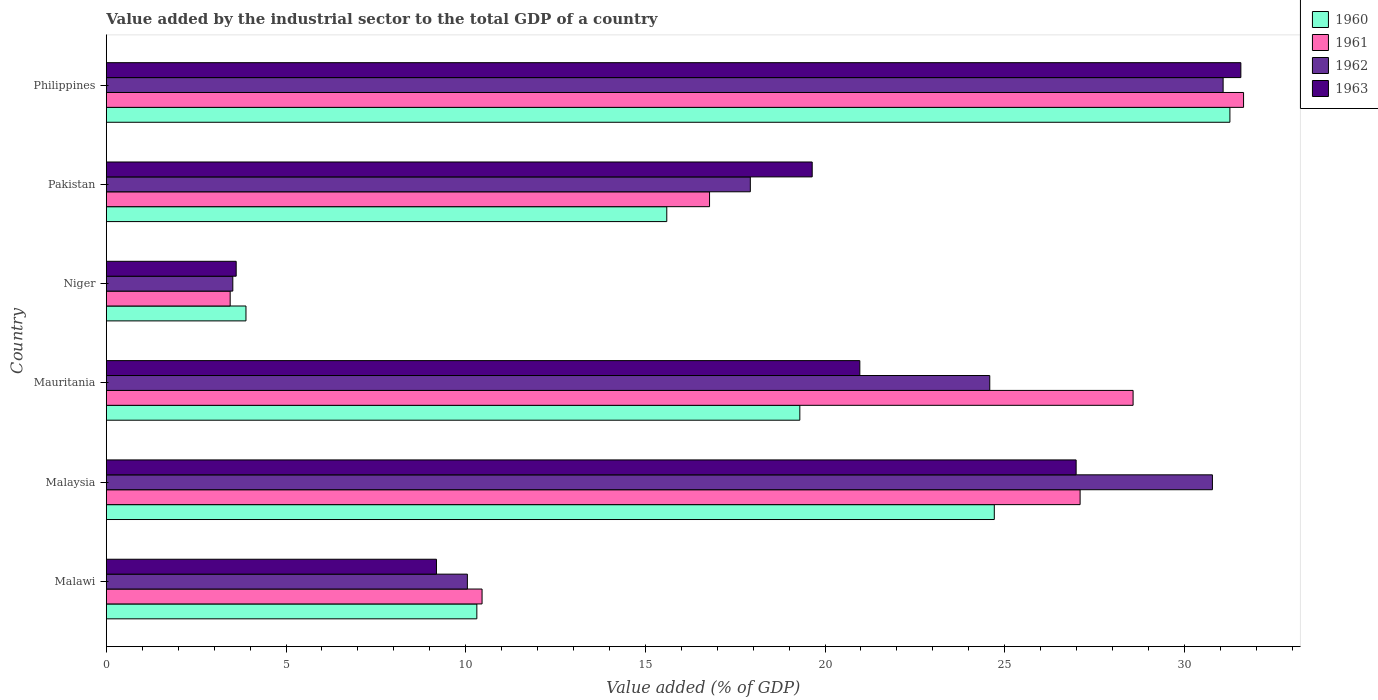How many different coloured bars are there?
Provide a succinct answer. 4. How many groups of bars are there?
Your answer should be very brief. 6. How many bars are there on the 4th tick from the top?
Make the answer very short. 4. What is the label of the 1st group of bars from the top?
Provide a short and direct response. Philippines. In how many cases, is the number of bars for a given country not equal to the number of legend labels?
Your answer should be very brief. 0. What is the value added by the industrial sector to the total GDP in 1960 in Malaysia?
Keep it short and to the point. 24.71. Across all countries, what is the maximum value added by the industrial sector to the total GDP in 1962?
Provide a short and direct response. 31.08. Across all countries, what is the minimum value added by the industrial sector to the total GDP in 1963?
Ensure brevity in your answer.  3.61. In which country was the value added by the industrial sector to the total GDP in 1962 maximum?
Make the answer very short. Philippines. In which country was the value added by the industrial sector to the total GDP in 1961 minimum?
Provide a short and direct response. Niger. What is the total value added by the industrial sector to the total GDP in 1962 in the graph?
Provide a short and direct response. 117.94. What is the difference between the value added by the industrial sector to the total GDP in 1962 in Niger and that in Pakistan?
Provide a short and direct response. -14.4. What is the difference between the value added by the industrial sector to the total GDP in 1960 in Niger and the value added by the industrial sector to the total GDP in 1963 in Philippines?
Provide a short and direct response. -27.69. What is the average value added by the industrial sector to the total GDP in 1962 per country?
Give a very brief answer. 19.66. What is the difference between the value added by the industrial sector to the total GDP in 1963 and value added by the industrial sector to the total GDP in 1960 in Malaysia?
Your answer should be compact. 2.28. What is the ratio of the value added by the industrial sector to the total GDP in 1962 in Mauritania to that in Pakistan?
Your answer should be very brief. 1.37. Is the difference between the value added by the industrial sector to the total GDP in 1963 in Malawi and Pakistan greater than the difference between the value added by the industrial sector to the total GDP in 1960 in Malawi and Pakistan?
Offer a terse response. No. What is the difference between the highest and the second highest value added by the industrial sector to the total GDP in 1960?
Your answer should be very brief. 6.56. What is the difference between the highest and the lowest value added by the industrial sector to the total GDP in 1960?
Your answer should be very brief. 27.38. How many bars are there?
Keep it short and to the point. 24. What is the difference between two consecutive major ticks on the X-axis?
Keep it short and to the point. 5. Are the values on the major ticks of X-axis written in scientific E-notation?
Ensure brevity in your answer.  No. Where does the legend appear in the graph?
Your response must be concise. Top right. What is the title of the graph?
Ensure brevity in your answer.  Value added by the industrial sector to the total GDP of a country. What is the label or title of the X-axis?
Your answer should be very brief. Value added (% of GDP). What is the Value added (% of GDP) in 1960 in Malawi?
Provide a succinct answer. 10.31. What is the Value added (% of GDP) of 1961 in Malawi?
Make the answer very short. 10.46. What is the Value added (% of GDP) in 1962 in Malawi?
Provide a short and direct response. 10.05. What is the Value added (% of GDP) of 1963 in Malawi?
Your answer should be very brief. 9.19. What is the Value added (% of GDP) of 1960 in Malaysia?
Give a very brief answer. 24.71. What is the Value added (% of GDP) in 1961 in Malaysia?
Offer a very short reply. 27.1. What is the Value added (% of GDP) of 1962 in Malaysia?
Your answer should be compact. 30.78. What is the Value added (% of GDP) of 1963 in Malaysia?
Your answer should be compact. 26.99. What is the Value added (% of GDP) in 1960 in Mauritania?
Provide a succinct answer. 19.3. What is the Value added (% of GDP) of 1961 in Mauritania?
Your response must be concise. 28.57. What is the Value added (% of GDP) in 1962 in Mauritania?
Ensure brevity in your answer.  24.59. What is the Value added (% of GDP) in 1963 in Mauritania?
Keep it short and to the point. 20.97. What is the Value added (% of GDP) in 1960 in Niger?
Make the answer very short. 3.89. What is the Value added (% of GDP) in 1961 in Niger?
Keep it short and to the point. 3.45. What is the Value added (% of GDP) in 1962 in Niger?
Your answer should be very brief. 3.52. What is the Value added (% of GDP) in 1963 in Niger?
Your response must be concise. 3.61. What is the Value added (% of GDP) in 1960 in Pakistan?
Provide a succinct answer. 15.6. What is the Value added (% of GDP) of 1961 in Pakistan?
Your answer should be compact. 16.79. What is the Value added (% of GDP) of 1962 in Pakistan?
Keep it short and to the point. 17.92. What is the Value added (% of GDP) in 1963 in Pakistan?
Provide a short and direct response. 19.64. What is the Value added (% of GDP) in 1960 in Philippines?
Your response must be concise. 31.27. What is the Value added (% of GDP) in 1961 in Philippines?
Provide a short and direct response. 31.65. What is the Value added (% of GDP) in 1962 in Philippines?
Give a very brief answer. 31.08. What is the Value added (% of GDP) of 1963 in Philippines?
Offer a terse response. 31.57. Across all countries, what is the maximum Value added (% of GDP) of 1960?
Keep it short and to the point. 31.27. Across all countries, what is the maximum Value added (% of GDP) of 1961?
Ensure brevity in your answer.  31.65. Across all countries, what is the maximum Value added (% of GDP) in 1962?
Your answer should be compact. 31.08. Across all countries, what is the maximum Value added (% of GDP) of 1963?
Give a very brief answer. 31.57. Across all countries, what is the minimum Value added (% of GDP) in 1960?
Your response must be concise. 3.89. Across all countries, what is the minimum Value added (% of GDP) in 1961?
Offer a very short reply. 3.45. Across all countries, what is the minimum Value added (% of GDP) in 1962?
Your answer should be compact. 3.52. Across all countries, what is the minimum Value added (% of GDP) in 1963?
Your response must be concise. 3.61. What is the total Value added (% of GDP) of 1960 in the graph?
Your answer should be compact. 105.07. What is the total Value added (% of GDP) of 1961 in the graph?
Make the answer very short. 118.01. What is the total Value added (% of GDP) in 1962 in the graph?
Your answer should be compact. 117.94. What is the total Value added (% of GDP) of 1963 in the graph?
Offer a terse response. 111.98. What is the difference between the Value added (% of GDP) of 1960 in Malawi and that in Malaysia?
Ensure brevity in your answer.  -14.4. What is the difference between the Value added (% of GDP) of 1961 in Malawi and that in Malaysia?
Your answer should be compact. -16.64. What is the difference between the Value added (% of GDP) of 1962 in Malawi and that in Malaysia?
Keep it short and to the point. -20.73. What is the difference between the Value added (% of GDP) in 1963 in Malawi and that in Malaysia?
Offer a very short reply. -17.8. What is the difference between the Value added (% of GDP) of 1960 in Malawi and that in Mauritania?
Provide a short and direct response. -8.99. What is the difference between the Value added (% of GDP) in 1961 in Malawi and that in Mauritania?
Ensure brevity in your answer.  -18.12. What is the difference between the Value added (% of GDP) of 1962 in Malawi and that in Mauritania?
Provide a short and direct response. -14.54. What is the difference between the Value added (% of GDP) of 1963 in Malawi and that in Mauritania?
Provide a short and direct response. -11.78. What is the difference between the Value added (% of GDP) of 1960 in Malawi and that in Niger?
Your answer should be compact. 6.43. What is the difference between the Value added (% of GDP) of 1961 in Malawi and that in Niger?
Your response must be concise. 7.01. What is the difference between the Value added (% of GDP) of 1962 in Malawi and that in Niger?
Your response must be concise. 6.53. What is the difference between the Value added (% of GDP) in 1963 in Malawi and that in Niger?
Offer a terse response. 5.57. What is the difference between the Value added (% of GDP) of 1960 in Malawi and that in Pakistan?
Your response must be concise. -5.29. What is the difference between the Value added (% of GDP) in 1961 in Malawi and that in Pakistan?
Give a very brief answer. -6.33. What is the difference between the Value added (% of GDP) in 1962 in Malawi and that in Pakistan?
Provide a succinct answer. -7.87. What is the difference between the Value added (% of GDP) in 1963 in Malawi and that in Pakistan?
Your answer should be compact. -10.46. What is the difference between the Value added (% of GDP) in 1960 in Malawi and that in Philippines?
Provide a succinct answer. -20.96. What is the difference between the Value added (% of GDP) of 1961 in Malawi and that in Philippines?
Your response must be concise. -21.19. What is the difference between the Value added (% of GDP) in 1962 in Malawi and that in Philippines?
Your answer should be very brief. -21.03. What is the difference between the Value added (% of GDP) of 1963 in Malawi and that in Philippines?
Offer a very short reply. -22.39. What is the difference between the Value added (% of GDP) in 1960 in Malaysia and that in Mauritania?
Your answer should be compact. 5.41. What is the difference between the Value added (% of GDP) of 1961 in Malaysia and that in Mauritania?
Your response must be concise. -1.47. What is the difference between the Value added (% of GDP) in 1962 in Malaysia and that in Mauritania?
Ensure brevity in your answer.  6.2. What is the difference between the Value added (% of GDP) of 1963 in Malaysia and that in Mauritania?
Make the answer very short. 6.02. What is the difference between the Value added (% of GDP) in 1960 in Malaysia and that in Niger?
Give a very brief answer. 20.83. What is the difference between the Value added (% of GDP) of 1961 in Malaysia and that in Niger?
Make the answer very short. 23.65. What is the difference between the Value added (% of GDP) in 1962 in Malaysia and that in Niger?
Ensure brevity in your answer.  27.26. What is the difference between the Value added (% of GDP) in 1963 in Malaysia and that in Niger?
Give a very brief answer. 23.38. What is the difference between the Value added (% of GDP) of 1960 in Malaysia and that in Pakistan?
Offer a very short reply. 9.11. What is the difference between the Value added (% of GDP) of 1961 in Malaysia and that in Pakistan?
Provide a succinct answer. 10.31. What is the difference between the Value added (% of GDP) of 1962 in Malaysia and that in Pakistan?
Ensure brevity in your answer.  12.86. What is the difference between the Value added (% of GDP) in 1963 in Malaysia and that in Pakistan?
Your answer should be compact. 7.35. What is the difference between the Value added (% of GDP) in 1960 in Malaysia and that in Philippines?
Offer a very short reply. -6.56. What is the difference between the Value added (% of GDP) in 1961 in Malaysia and that in Philippines?
Your response must be concise. -4.55. What is the difference between the Value added (% of GDP) of 1962 in Malaysia and that in Philippines?
Offer a very short reply. -0.3. What is the difference between the Value added (% of GDP) of 1963 in Malaysia and that in Philippines?
Your answer should be very brief. -4.58. What is the difference between the Value added (% of GDP) of 1960 in Mauritania and that in Niger?
Keep it short and to the point. 15.41. What is the difference between the Value added (% of GDP) of 1961 in Mauritania and that in Niger?
Make the answer very short. 25.13. What is the difference between the Value added (% of GDP) of 1962 in Mauritania and that in Niger?
Your answer should be compact. 21.07. What is the difference between the Value added (% of GDP) in 1963 in Mauritania and that in Niger?
Your answer should be very brief. 17.36. What is the difference between the Value added (% of GDP) in 1960 in Mauritania and that in Pakistan?
Make the answer very short. 3.7. What is the difference between the Value added (% of GDP) in 1961 in Mauritania and that in Pakistan?
Your response must be concise. 11.79. What is the difference between the Value added (% of GDP) in 1962 in Mauritania and that in Pakistan?
Your answer should be compact. 6.66. What is the difference between the Value added (% of GDP) of 1963 in Mauritania and that in Pakistan?
Ensure brevity in your answer.  1.33. What is the difference between the Value added (% of GDP) of 1960 in Mauritania and that in Philippines?
Provide a succinct answer. -11.97. What is the difference between the Value added (% of GDP) in 1961 in Mauritania and that in Philippines?
Your answer should be compact. -3.07. What is the difference between the Value added (% of GDP) in 1962 in Mauritania and that in Philippines?
Offer a very short reply. -6.49. What is the difference between the Value added (% of GDP) of 1963 in Mauritania and that in Philippines?
Make the answer very short. -10.6. What is the difference between the Value added (% of GDP) of 1960 in Niger and that in Pakistan?
Provide a succinct answer. -11.71. What is the difference between the Value added (% of GDP) in 1961 in Niger and that in Pakistan?
Provide a short and direct response. -13.34. What is the difference between the Value added (% of GDP) of 1962 in Niger and that in Pakistan?
Give a very brief answer. -14.4. What is the difference between the Value added (% of GDP) of 1963 in Niger and that in Pakistan?
Provide a succinct answer. -16.03. What is the difference between the Value added (% of GDP) of 1960 in Niger and that in Philippines?
Your answer should be very brief. -27.38. What is the difference between the Value added (% of GDP) in 1961 in Niger and that in Philippines?
Make the answer very short. -28.2. What is the difference between the Value added (% of GDP) in 1962 in Niger and that in Philippines?
Offer a terse response. -27.56. What is the difference between the Value added (% of GDP) of 1963 in Niger and that in Philippines?
Ensure brevity in your answer.  -27.96. What is the difference between the Value added (% of GDP) in 1960 in Pakistan and that in Philippines?
Your answer should be compact. -15.67. What is the difference between the Value added (% of GDP) of 1961 in Pakistan and that in Philippines?
Keep it short and to the point. -14.86. What is the difference between the Value added (% of GDP) of 1962 in Pakistan and that in Philippines?
Your response must be concise. -13.16. What is the difference between the Value added (% of GDP) in 1963 in Pakistan and that in Philippines?
Provide a succinct answer. -11.93. What is the difference between the Value added (% of GDP) of 1960 in Malawi and the Value added (% of GDP) of 1961 in Malaysia?
Ensure brevity in your answer.  -16.79. What is the difference between the Value added (% of GDP) in 1960 in Malawi and the Value added (% of GDP) in 1962 in Malaysia?
Provide a short and direct response. -20.47. What is the difference between the Value added (% of GDP) in 1960 in Malawi and the Value added (% of GDP) in 1963 in Malaysia?
Make the answer very short. -16.68. What is the difference between the Value added (% of GDP) of 1961 in Malawi and the Value added (% of GDP) of 1962 in Malaysia?
Ensure brevity in your answer.  -20.33. What is the difference between the Value added (% of GDP) in 1961 in Malawi and the Value added (% of GDP) in 1963 in Malaysia?
Offer a terse response. -16.53. What is the difference between the Value added (% of GDP) in 1962 in Malawi and the Value added (% of GDP) in 1963 in Malaysia?
Provide a succinct answer. -16.94. What is the difference between the Value added (% of GDP) in 1960 in Malawi and the Value added (% of GDP) in 1961 in Mauritania?
Provide a short and direct response. -18.26. What is the difference between the Value added (% of GDP) in 1960 in Malawi and the Value added (% of GDP) in 1962 in Mauritania?
Offer a terse response. -14.27. What is the difference between the Value added (% of GDP) in 1960 in Malawi and the Value added (% of GDP) in 1963 in Mauritania?
Your response must be concise. -10.66. What is the difference between the Value added (% of GDP) of 1961 in Malawi and the Value added (% of GDP) of 1962 in Mauritania?
Your answer should be compact. -14.13. What is the difference between the Value added (% of GDP) in 1961 in Malawi and the Value added (% of GDP) in 1963 in Mauritania?
Make the answer very short. -10.51. What is the difference between the Value added (% of GDP) in 1962 in Malawi and the Value added (% of GDP) in 1963 in Mauritania?
Offer a very short reply. -10.92. What is the difference between the Value added (% of GDP) of 1960 in Malawi and the Value added (% of GDP) of 1961 in Niger?
Ensure brevity in your answer.  6.86. What is the difference between the Value added (% of GDP) of 1960 in Malawi and the Value added (% of GDP) of 1962 in Niger?
Offer a very short reply. 6.79. What is the difference between the Value added (% of GDP) in 1960 in Malawi and the Value added (% of GDP) in 1963 in Niger?
Provide a succinct answer. 6.7. What is the difference between the Value added (% of GDP) of 1961 in Malawi and the Value added (% of GDP) of 1962 in Niger?
Offer a very short reply. 6.94. What is the difference between the Value added (% of GDP) of 1961 in Malawi and the Value added (% of GDP) of 1963 in Niger?
Provide a short and direct response. 6.84. What is the difference between the Value added (% of GDP) in 1962 in Malawi and the Value added (% of GDP) in 1963 in Niger?
Make the answer very short. 6.43. What is the difference between the Value added (% of GDP) of 1960 in Malawi and the Value added (% of GDP) of 1961 in Pakistan?
Your answer should be very brief. -6.48. What is the difference between the Value added (% of GDP) in 1960 in Malawi and the Value added (% of GDP) in 1962 in Pakistan?
Your answer should be very brief. -7.61. What is the difference between the Value added (% of GDP) of 1960 in Malawi and the Value added (% of GDP) of 1963 in Pakistan?
Give a very brief answer. -9.33. What is the difference between the Value added (% of GDP) in 1961 in Malawi and the Value added (% of GDP) in 1962 in Pakistan?
Your response must be concise. -7.47. What is the difference between the Value added (% of GDP) in 1961 in Malawi and the Value added (% of GDP) in 1963 in Pakistan?
Ensure brevity in your answer.  -9.19. What is the difference between the Value added (% of GDP) in 1962 in Malawi and the Value added (% of GDP) in 1963 in Pakistan?
Provide a succinct answer. -9.6. What is the difference between the Value added (% of GDP) of 1960 in Malawi and the Value added (% of GDP) of 1961 in Philippines?
Give a very brief answer. -21.34. What is the difference between the Value added (% of GDP) of 1960 in Malawi and the Value added (% of GDP) of 1962 in Philippines?
Give a very brief answer. -20.77. What is the difference between the Value added (% of GDP) in 1960 in Malawi and the Value added (% of GDP) in 1963 in Philippines?
Your answer should be compact. -21.26. What is the difference between the Value added (% of GDP) of 1961 in Malawi and the Value added (% of GDP) of 1962 in Philippines?
Your answer should be compact. -20.62. What is the difference between the Value added (% of GDP) in 1961 in Malawi and the Value added (% of GDP) in 1963 in Philippines?
Offer a terse response. -21.12. What is the difference between the Value added (% of GDP) of 1962 in Malawi and the Value added (% of GDP) of 1963 in Philippines?
Give a very brief answer. -21.53. What is the difference between the Value added (% of GDP) in 1960 in Malaysia and the Value added (% of GDP) in 1961 in Mauritania?
Ensure brevity in your answer.  -3.86. What is the difference between the Value added (% of GDP) of 1960 in Malaysia and the Value added (% of GDP) of 1962 in Mauritania?
Your answer should be compact. 0.13. What is the difference between the Value added (% of GDP) of 1960 in Malaysia and the Value added (% of GDP) of 1963 in Mauritania?
Provide a short and direct response. 3.74. What is the difference between the Value added (% of GDP) in 1961 in Malaysia and the Value added (% of GDP) in 1962 in Mauritania?
Offer a terse response. 2.51. What is the difference between the Value added (% of GDP) in 1961 in Malaysia and the Value added (% of GDP) in 1963 in Mauritania?
Provide a short and direct response. 6.13. What is the difference between the Value added (% of GDP) of 1962 in Malaysia and the Value added (% of GDP) of 1963 in Mauritania?
Offer a very short reply. 9.81. What is the difference between the Value added (% of GDP) of 1960 in Malaysia and the Value added (% of GDP) of 1961 in Niger?
Offer a terse response. 21.27. What is the difference between the Value added (% of GDP) in 1960 in Malaysia and the Value added (% of GDP) in 1962 in Niger?
Offer a terse response. 21.19. What is the difference between the Value added (% of GDP) of 1960 in Malaysia and the Value added (% of GDP) of 1963 in Niger?
Ensure brevity in your answer.  21.1. What is the difference between the Value added (% of GDP) in 1961 in Malaysia and the Value added (% of GDP) in 1962 in Niger?
Your answer should be compact. 23.58. What is the difference between the Value added (% of GDP) in 1961 in Malaysia and the Value added (% of GDP) in 1963 in Niger?
Give a very brief answer. 23.49. What is the difference between the Value added (% of GDP) in 1962 in Malaysia and the Value added (% of GDP) in 1963 in Niger?
Your answer should be very brief. 27.17. What is the difference between the Value added (% of GDP) in 1960 in Malaysia and the Value added (% of GDP) in 1961 in Pakistan?
Your answer should be compact. 7.92. What is the difference between the Value added (% of GDP) in 1960 in Malaysia and the Value added (% of GDP) in 1962 in Pakistan?
Your answer should be compact. 6.79. What is the difference between the Value added (% of GDP) of 1960 in Malaysia and the Value added (% of GDP) of 1963 in Pakistan?
Offer a terse response. 5.07. What is the difference between the Value added (% of GDP) of 1961 in Malaysia and the Value added (% of GDP) of 1962 in Pakistan?
Your answer should be compact. 9.18. What is the difference between the Value added (% of GDP) of 1961 in Malaysia and the Value added (% of GDP) of 1963 in Pakistan?
Your answer should be compact. 7.46. What is the difference between the Value added (% of GDP) of 1962 in Malaysia and the Value added (% of GDP) of 1963 in Pakistan?
Your answer should be very brief. 11.14. What is the difference between the Value added (% of GDP) in 1960 in Malaysia and the Value added (% of GDP) in 1961 in Philippines?
Offer a terse response. -6.94. What is the difference between the Value added (% of GDP) in 1960 in Malaysia and the Value added (% of GDP) in 1962 in Philippines?
Your response must be concise. -6.37. What is the difference between the Value added (% of GDP) of 1960 in Malaysia and the Value added (% of GDP) of 1963 in Philippines?
Keep it short and to the point. -6.86. What is the difference between the Value added (% of GDP) of 1961 in Malaysia and the Value added (% of GDP) of 1962 in Philippines?
Provide a short and direct response. -3.98. What is the difference between the Value added (% of GDP) in 1961 in Malaysia and the Value added (% of GDP) in 1963 in Philippines?
Provide a short and direct response. -4.47. What is the difference between the Value added (% of GDP) in 1962 in Malaysia and the Value added (% of GDP) in 1963 in Philippines?
Provide a succinct answer. -0.79. What is the difference between the Value added (% of GDP) in 1960 in Mauritania and the Value added (% of GDP) in 1961 in Niger?
Provide a succinct answer. 15.85. What is the difference between the Value added (% of GDP) in 1960 in Mauritania and the Value added (% of GDP) in 1962 in Niger?
Provide a succinct answer. 15.78. What is the difference between the Value added (% of GDP) in 1960 in Mauritania and the Value added (% of GDP) in 1963 in Niger?
Your answer should be compact. 15.69. What is the difference between the Value added (% of GDP) in 1961 in Mauritania and the Value added (% of GDP) in 1962 in Niger?
Make the answer very short. 25.05. What is the difference between the Value added (% of GDP) in 1961 in Mauritania and the Value added (% of GDP) in 1963 in Niger?
Ensure brevity in your answer.  24.96. What is the difference between the Value added (% of GDP) of 1962 in Mauritania and the Value added (% of GDP) of 1963 in Niger?
Ensure brevity in your answer.  20.97. What is the difference between the Value added (% of GDP) of 1960 in Mauritania and the Value added (% of GDP) of 1961 in Pakistan?
Offer a very short reply. 2.51. What is the difference between the Value added (% of GDP) of 1960 in Mauritania and the Value added (% of GDP) of 1962 in Pakistan?
Give a very brief answer. 1.38. What is the difference between the Value added (% of GDP) in 1960 in Mauritania and the Value added (% of GDP) in 1963 in Pakistan?
Provide a succinct answer. -0.34. What is the difference between the Value added (% of GDP) of 1961 in Mauritania and the Value added (% of GDP) of 1962 in Pakistan?
Keep it short and to the point. 10.65. What is the difference between the Value added (% of GDP) of 1961 in Mauritania and the Value added (% of GDP) of 1963 in Pakistan?
Offer a terse response. 8.93. What is the difference between the Value added (% of GDP) of 1962 in Mauritania and the Value added (% of GDP) of 1963 in Pakistan?
Make the answer very short. 4.94. What is the difference between the Value added (% of GDP) of 1960 in Mauritania and the Value added (% of GDP) of 1961 in Philippines?
Offer a terse response. -12.35. What is the difference between the Value added (% of GDP) in 1960 in Mauritania and the Value added (% of GDP) in 1962 in Philippines?
Your response must be concise. -11.78. What is the difference between the Value added (% of GDP) of 1960 in Mauritania and the Value added (% of GDP) of 1963 in Philippines?
Make the answer very short. -12.27. What is the difference between the Value added (% of GDP) in 1961 in Mauritania and the Value added (% of GDP) in 1962 in Philippines?
Give a very brief answer. -2.51. What is the difference between the Value added (% of GDP) in 1961 in Mauritania and the Value added (% of GDP) in 1963 in Philippines?
Offer a very short reply. -3. What is the difference between the Value added (% of GDP) of 1962 in Mauritania and the Value added (% of GDP) of 1963 in Philippines?
Provide a succinct answer. -6.99. What is the difference between the Value added (% of GDP) of 1960 in Niger and the Value added (% of GDP) of 1961 in Pakistan?
Offer a very short reply. -12.9. What is the difference between the Value added (% of GDP) in 1960 in Niger and the Value added (% of GDP) in 1962 in Pakistan?
Make the answer very short. -14.04. What is the difference between the Value added (% of GDP) of 1960 in Niger and the Value added (% of GDP) of 1963 in Pakistan?
Make the answer very short. -15.76. What is the difference between the Value added (% of GDP) of 1961 in Niger and the Value added (% of GDP) of 1962 in Pakistan?
Provide a succinct answer. -14.48. What is the difference between the Value added (% of GDP) of 1961 in Niger and the Value added (% of GDP) of 1963 in Pakistan?
Offer a terse response. -16.2. What is the difference between the Value added (% of GDP) of 1962 in Niger and the Value added (% of GDP) of 1963 in Pakistan?
Ensure brevity in your answer.  -16.12. What is the difference between the Value added (% of GDP) of 1960 in Niger and the Value added (% of GDP) of 1961 in Philippines?
Keep it short and to the point. -27.76. What is the difference between the Value added (% of GDP) in 1960 in Niger and the Value added (% of GDP) in 1962 in Philippines?
Offer a very short reply. -27.19. What is the difference between the Value added (% of GDP) in 1960 in Niger and the Value added (% of GDP) in 1963 in Philippines?
Your answer should be compact. -27.69. What is the difference between the Value added (% of GDP) of 1961 in Niger and the Value added (% of GDP) of 1962 in Philippines?
Your response must be concise. -27.63. What is the difference between the Value added (% of GDP) in 1961 in Niger and the Value added (% of GDP) in 1963 in Philippines?
Your response must be concise. -28.13. What is the difference between the Value added (% of GDP) of 1962 in Niger and the Value added (% of GDP) of 1963 in Philippines?
Offer a terse response. -28.05. What is the difference between the Value added (% of GDP) in 1960 in Pakistan and the Value added (% of GDP) in 1961 in Philippines?
Your response must be concise. -16.05. What is the difference between the Value added (% of GDP) in 1960 in Pakistan and the Value added (% of GDP) in 1962 in Philippines?
Your response must be concise. -15.48. What is the difference between the Value added (% of GDP) in 1960 in Pakistan and the Value added (% of GDP) in 1963 in Philippines?
Give a very brief answer. -15.98. What is the difference between the Value added (% of GDP) of 1961 in Pakistan and the Value added (% of GDP) of 1962 in Philippines?
Make the answer very short. -14.29. What is the difference between the Value added (% of GDP) in 1961 in Pakistan and the Value added (% of GDP) in 1963 in Philippines?
Provide a short and direct response. -14.79. What is the difference between the Value added (% of GDP) of 1962 in Pakistan and the Value added (% of GDP) of 1963 in Philippines?
Provide a short and direct response. -13.65. What is the average Value added (% of GDP) in 1960 per country?
Offer a very short reply. 17.51. What is the average Value added (% of GDP) of 1961 per country?
Your answer should be very brief. 19.67. What is the average Value added (% of GDP) of 1962 per country?
Provide a succinct answer. 19.66. What is the average Value added (% of GDP) in 1963 per country?
Offer a terse response. 18.66. What is the difference between the Value added (% of GDP) in 1960 and Value added (% of GDP) in 1961 in Malawi?
Ensure brevity in your answer.  -0.15. What is the difference between the Value added (% of GDP) of 1960 and Value added (% of GDP) of 1962 in Malawi?
Your answer should be compact. 0.26. What is the difference between the Value added (% of GDP) of 1960 and Value added (% of GDP) of 1963 in Malawi?
Keep it short and to the point. 1.12. What is the difference between the Value added (% of GDP) of 1961 and Value added (% of GDP) of 1962 in Malawi?
Your response must be concise. 0.41. What is the difference between the Value added (% of GDP) of 1961 and Value added (% of GDP) of 1963 in Malawi?
Make the answer very short. 1.27. What is the difference between the Value added (% of GDP) in 1962 and Value added (% of GDP) in 1963 in Malawi?
Your answer should be compact. 0.86. What is the difference between the Value added (% of GDP) of 1960 and Value added (% of GDP) of 1961 in Malaysia?
Keep it short and to the point. -2.39. What is the difference between the Value added (% of GDP) of 1960 and Value added (% of GDP) of 1962 in Malaysia?
Provide a succinct answer. -6.07. What is the difference between the Value added (% of GDP) of 1960 and Value added (% of GDP) of 1963 in Malaysia?
Offer a terse response. -2.28. What is the difference between the Value added (% of GDP) in 1961 and Value added (% of GDP) in 1962 in Malaysia?
Your answer should be compact. -3.68. What is the difference between the Value added (% of GDP) in 1961 and Value added (% of GDP) in 1963 in Malaysia?
Offer a very short reply. 0.11. What is the difference between the Value added (% of GDP) in 1962 and Value added (% of GDP) in 1963 in Malaysia?
Offer a very short reply. 3.79. What is the difference between the Value added (% of GDP) of 1960 and Value added (% of GDP) of 1961 in Mauritania?
Make the answer very short. -9.27. What is the difference between the Value added (% of GDP) of 1960 and Value added (% of GDP) of 1962 in Mauritania?
Give a very brief answer. -5.29. What is the difference between the Value added (% of GDP) in 1960 and Value added (% of GDP) in 1963 in Mauritania?
Provide a succinct answer. -1.67. What is the difference between the Value added (% of GDP) in 1961 and Value added (% of GDP) in 1962 in Mauritania?
Offer a very short reply. 3.99. What is the difference between the Value added (% of GDP) of 1961 and Value added (% of GDP) of 1963 in Mauritania?
Your answer should be compact. 7.6. What is the difference between the Value added (% of GDP) in 1962 and Value added (% of GDP) in 1963 in Mauritania?
Provide a succinct answer. 3.62. What is the difference between the Value added (% of GDP) of 1960 and Value added (% of GDP) of 1961 in Niger?
Keep it short and to the point. 0.44. What is the difference between the Value added (% of GDP) in 1960 and Value added (% of GDP) in 1962 in Niger?
Provide a succinct answer. 0.37. What is the difference between the Value added (% of GDP) of 1960 and Value added (% of GDP) of 1963 in Niger?
Offer a terse response. 0.27. What is the difference between the Value added (% of GDP) in 1961 and Value added (% of GDP) in 1962 in Niger?
Your response must be concise. -0.07. What is the difference between the Value added (% of GDP) of 1961 and Value added (% of GDP) of 1963 in Niger?
Offer a very short reply. -0.17. What is the difference between the Value added (% of GDP) in 1962 and Value added (% of GDP) in 1963 in Niger?
Your response must be concise. -0.09. What is the difference between the Value added (% of GDP) of 1960 and Value added (% of GDP) of 1961 in Pakistan?
Make the answer very short. -1.19. What is the difference between the Value added (% of GDP) of 1960 and Value added (% of GDP) of 1962 in Pakistan?
Your answer should be compact. -2.33. What is the difference between the Value added (% of GDP) of 1960 and Value added (% of GDP) of 1963 in Pakistan?
Your response must be concise. -4.05. What is the difference between the Value added (% of GDP) in 1961 and Value added (% of GDP) in 1962 in Pakistan?
Offer a very short reply. -1.14. What is the difference between the Value added (% of GDP) in 1961 and Value added (% of GDP) in 1963 in Pakistan?
Provide a succinct answer. -2.86. What is the difference between the Value added (% of GDP) of 1962 and Value added (% of GDP) of 1963 in Pakistan?
Ensure brevity in your answer.  -1.72. What is the difference between the Value added (% of GDP) of 1960 and Value added (% of GDP) of 1961 in Philippines?
Your answer should be very brief. -0.38. What is the difference between the Value added (% of GDP) in 1960 and Value added (% of GDP) in 1962 in Philippines?
Offer a very short reply. 0.19. What is the difference between the Value added (% of GDP) in 1960 and Value added (% of GDP) in 1963 in Philippines?
Your answer should be compact. -0.3. What is the difference between the Value added (% of GDP) in 1961 and Value added (% of GDP) in 1962 in Philippines?
Your answer should be compact. 0.57. What is the difference between the Value added (% of GDP) in 1961 and Value added (% of GDP) in 1963 in Philippines?
Your response must be concise. 0.08. What is the difference between the Value added (% of GDP) in 1962 and Value added (% of GDP) in 1963 in Philippines?
Keep it short and to the point. -0.49. What is the ratio of the Value added (% of GDP) in 1960 in Malawi to that in Malaysia?
Offer a very short reply. 0.42. What is the ratio of the Value added (% of GDP) in 1961 in Malawi to that in Malaysia?
Give a very brief answer. 0.39. What is the ratio of the Value added (% of GDP) of 1962 in Malawi to that in Malaysia?
Your answer should be compact. 0.33. What is the ratio of the Value added (% of GDP) in 1963 in Malawi to that in Malaysia?
Offer a very short reply. 0.34. What is the ratio of the Value added (% of GDP) of 1960 in Malawi to that in Mauritania?
Your answer should be compact. 0.53. What is the ratio of the Value added (% of GDP) in 1961 in Malawi to that in Mauritania?
Provide a short and direct response. 0.37. What is the ratio of the Value added (% of GDP) in 1962 in Malawi to that in Mauritania?
Provide a short and direct response. 0.41. What is the ratio of the Value added (% of GDP) in 1963 in Malawi to that in Mauritania?
Ensure brevity in your answer.  0.44. What is the ratio of the Value added (% of GDP) of 1960 in Malawi to that in Niger?
Ensure brevity in your answer.  2.65. What is the ratio of the Value added (% of GDP) in 1961 in Malawi to that in Niger?
Offer a very short reply. 3.03. What is the ratio of the Value added (% of GDP) of 1962 in Malawi to that in Niger?
Your response must be concise. 2.85. What is the ratio of the Value added (% of GDP) in 1963 in Malawi to that in Niger?
Provide a short and direct response. 2.54. What is the ratio of the Value added (% of GDP) of 1960 in Malawi to that in Pakistan?
Offer a terse response. 0.66. What is the ratio of the Value added (% of GDP) in 1961 in Malawi to that in Pakistan?
Keep it short and to the point. 0.62. What is the ratio of the Value added (% of GDP) in 1962 in Malawi to that in Pakistan?
Your answer should be very brief. 0.56. What is the ratio of the Value added (% of GDP) in 1963 in Malawi to that in Pakistan?
Provide a succinct answer. 0.47. What is the ratio of the Value added (% of GDP) of 1960 in Malawi to that in Philippines?
Your answer should be very brief. 0.33. What is the ratio of the Value added (% of GDP) of 1961 in Malawi to that in Philippines?
Offer a very short reply. 0.33. What is the ratio of the Value added (% of GDP) of 1962 in Malawi to that in Philippines?
Your answer should be very brief. 0.32. What is the ratio of the Value added (% of GDP) in 1963 in Malawi to that in Philippines?
Your answer should be compact. 0.29. What is the ratio of the Value added (% of GDP) in 1960 in Malaysia to that in Mauritania?
Your answer should be compact. 1.28. What is the ratio of the Value added (% of GDP) of 1961 in Malaysia to that in Mauritania?
Offer a terse response. 0.95. What is the ratio of the Value added (% of GDP) in 1962 in Malaysia to that in Mauritania?
Give a very brief answer. 1.25. What is the ratio of the Value added (% of GDP) in 1963 in Malaysia to that in Mauritania?
Your answer should be very brief. 1.29. What is the ratio of the Value added (% of GDP) of 1960 in Malaysia to that in Niger?
Offer a terse response. 6.36. What is the ratio of the Value added (% of GDP) in 1961 in Malaysia to that in Niger?
Provide a short and direct response. 7.86. What is the ratio of the Value added (% of GDP) in 1962 in Malaysia to that in Niger?
Make the answer very short. 8.75. What is the ratio of the Value added (% of GDP) of 1963 in Malaysia to that in Niger?
Your response must be concise. 7.47. What is the ratio of the Value added (% of GDP) of 1960 in Malaysia to that in Pakistan?
Your answer should be very brief. 1.58. What is the ratio of the Value added (% of GDP) in 1961 in Malaysia to that in Pakistan?
Offer a very short reply. 1.61. What is the ratio of the Value added (% of GDP) in 1962 in Malaysia to that in Pakistan?
Provide a succinct answer. 1.72. What is the ratio of the Value added (% of GDP) in 1963 in Malaysia to that in Pakistan?
Keep it short and to the point. 1.37. What is the ratio of the Value added (% of GDP) in 1960 in Malaysia to that in Philippines?
Your answer should be compact. 0.79. What is the ratio of the Value added (% of GDP) of 1961 in Malaysia to that in Philippines?
Provide a short and direct response. 0.86. What is the ratio of the Value added (% of GDP) of 1963 in Malaysia to that in Philippines?
Your response must be concise. 0.85. What is the ratio of the Value added (% of GDP) in 1960 in Mauritania to that in Niger?
Ensure brevity in your answer.  4.97. What is the ratio of the Value added (% of GDP) of 1961 in Mauritania to that in Niger?
Provide a succinct answer. 8.29. What is the ratio of the Value added (% of GDP) in 1962 in Mauritania to that in Niger?
Your response must be concise. 6.99. What is the ratio of the Value added (% of GDP) in 1963 in Mauritania to that in Niger?
Give a very brief answer. 5.8. What is the ratio of the Value added (% of GDP) of 1960 in Mauritania to that in Pakistan?
Your response must be concise. 1.24. What is the ratio of the Value added (% of GDP) of 1961 in Mauritania to that in Pakistan?
Your answer should be very brief. 1.7. What is the ratio of the Value added (% of GDP) in 1962 in Mauritania to that in Pakistan?
Ensure brevity in your answer.  1.37. What is the ratio of the Value added (% of GDP) in 1963 in Mauritania to that in Pakistan?
Make the answer very short. 1.07. What is the ratio of the Value added (% of GDP) in 1960 in Mauritania to that in Philippines?
Your answer should be very brief. 0.62. What is the ratio of the Value added (% of GDP) of 1961 in Mauritania to that in Philippines?
Ensure brevity in your answer.  0.9. What is the ratio of the Value added (% of GDP) of 1962 in Mauritania to that in Philippines?
Your answer should be compact. 0.79. What is the ratio of the Value added (% of GDP) in 1963 in Mauritania to that in Philippines?
Your response must be concise. 0.66. What is the ratio of the Value added (% of GDP) of 1960 in Niger to that in Pakistan?
Your response must be concise. 0.25. What is the ratio of the Value added (% of GDP) of 1961 in Niger to that in Pakistan?
Your answer should be very brief. 0.21. What is the ratio of the Value added (% of GDP) in 1962 in Niger to that in Pakistan?
Make the answer very short. 0.2. What is the ratio of the Value added (% of GDP) in 1963 in Niger to that in Pakistan?
Give a very brief answer. 0.18. What is the ratio of the Value added (% of GDP) of 1960 in Niger to that in Philippines?
Offer a terse response. 0.12. What is the ratio of the Value added (% of GDP) of 1961 in Niger to that in Philippines?
Ensure brevity in your answer.  0.11. What is the ratio of the Value added (% of GDP) in 1962 in Niger to that in Philippines?
Provide a short and direct response. 0.11. What is the ratio of the Value added (% of GDP) in 1963 in Niger to that in Philippines?
Provide a succinct answer. 0.11. What is the ratio of the Value added (% of GDP) of 1960 in Pakistan to that in Philippines?
Your answer should be very brief. 0.5. What is the ratio of the Value added (% of GDP) of 1961 in Pakistan to that in Philippines?
Offer a terse response. 0.53. What is the ratio of the Value added (% of GDP) in 1962 in Pakistan to that in Philippines?
Your answer should be very brief. 0.58. What is the ratio of the Value added (% of GDP) of 1963 in Pakistan to that in Philippines?
Give a very brief answer. 0.62. What is the difference between the highest and the second highest Value added (% of GDP) in 1960?
Provide a succinct answer. 6.56. What is the difference between the highest and the second highest Value added (% of GDP) of 1961?
Provide a succinct answer. 3.07. What is the difference between the highest and the second highest Value added (% of GDP) in 1962?
Your response must be concise. 0.3. What is the difference between the highest and the second highest Value added (% of GDP) in 1963?
Ensure brevity in your answer.  4.58. What is the difference between the highest and the lowest Value added (% of GDP) of 1960?
Your response must be concise. 27.38. What is the difference between the highest and the lowest Value added (% of GDP) in 1961?
Your answer should be compact. 28.2. What is the difference between the highest and the lowest Value added (% of GDP) in 1962?
Provide a succinct answer. 27.56. What is the difference between the highest and the lowest Value added (% of GDP) of 1963?
Your answer should be very brief. 27.96. 